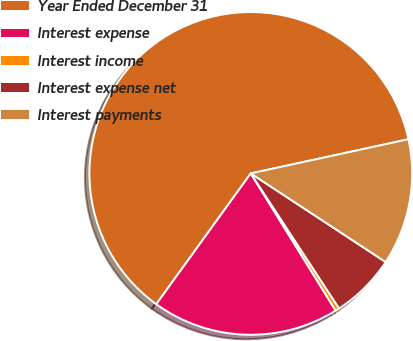Convert chart. <chart><loc_0><loc_0><loc_500><loc_500><pie_chart><fcel>Year Ended December 31<fcel>Interest expense<fcel>Interest income<fcel>Interest expense net<fcel>Interest payments<nl><fcel>61.65%<fcel>18.78%<fcel>0.4%<fcel>6.53%<fcel>12.65%<nl></chart> 